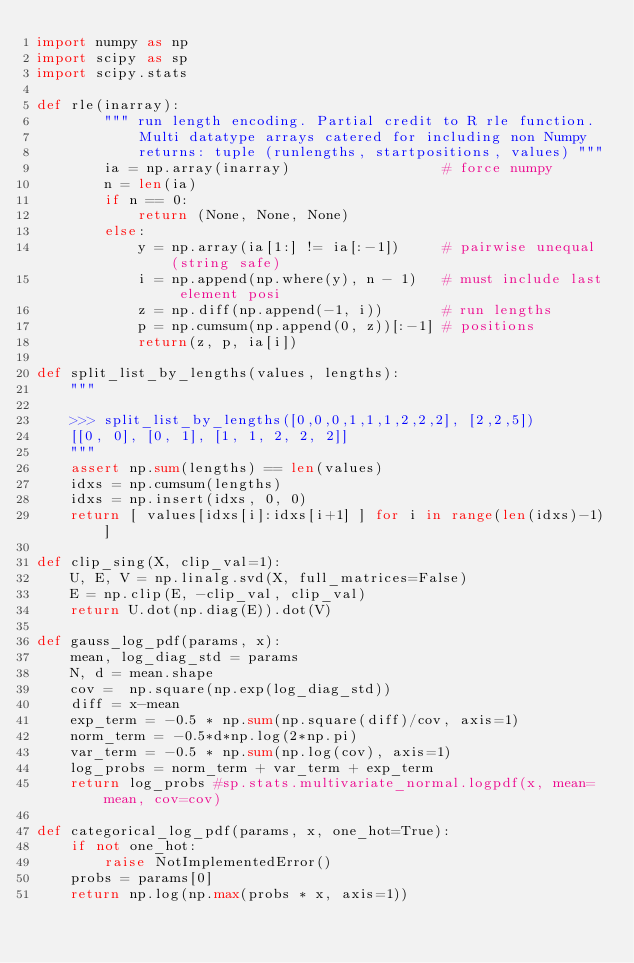<code> <loc_0><loc_0><loc_500><loc_500><_Python_>import numpy as np
import scipy as sp
import scipy.stats

def rle(inarray):
        """ run length encoding. Partial credit to R rle function. 
            Multi datatype arrays catered for including non Numpy
            returns: tuple (runlengths, startpositions, values) """
        ia = np.array(inarray)                  # force numpy
        n = len(ia)
        if n == 0: 
            return (None, None, None)
        else:
            y = np.array(ia[1:] != ia[:-1])     # pairwise unequal (string safe)
            i = np.append(np.where(y), n - 1)   # must include last element posi
            z = np.diff(np.append(-1, i))       # run lengths
            p = np.cumsum(np.append(0, z))[:-1] # positions
            return(z, p, ia[i])

def split_list_by_lengths(values, lengths):
    """

    >>> split_list_by_lengths([0,0,0,1,1,1,2,2,2], [2,2,5])
    [[0, 0], [0, 1], [1, 1, 2, 2, 2]]
    """
    assert np.sum(lengths) == len(values)
    idxs = np.cumsum(lengths)
    idxs = np.insert(idxs, 0, 0)
    return [ values[idxs[i]:idxs[i+1] ] for i in range(len(idxs)-1)]

def clip_sing(X, clip_val=1):
    U, E, V = np.linalg.svd(X, full_matrices=False)
    E = np.clip(E, -clip_val, clip_val)
    return U.dot(np.diag(E)).dot(V)

def gauss_log_pdf(params, x):
    mean, log_diag_std = params
    N, d = mean.shape
    cov =  np.square(np.exp(log_diag_std))
    diff = x-mean
    exp_term = -0.5 * np.sum(np.square(diff)/cov, axis=1)
    norm_term = -0.5*d*np.log(2*np.pi)
    var_term = -0.5 * np.sum(np.log(cov), axis=1)
    log_probs = norm_term + var_term + exp_term
    return log_probs #sp.stats.multivariate_normal.logpdf(x, mean=mean, cov=cov)

def categorical_log_pdf(params, x, one_hot=True):
    if not one_hot:
        raise NotImplementedError()
    probs = params[0]
    return np.log(np.max(probs * x, axis=1))

</code> 